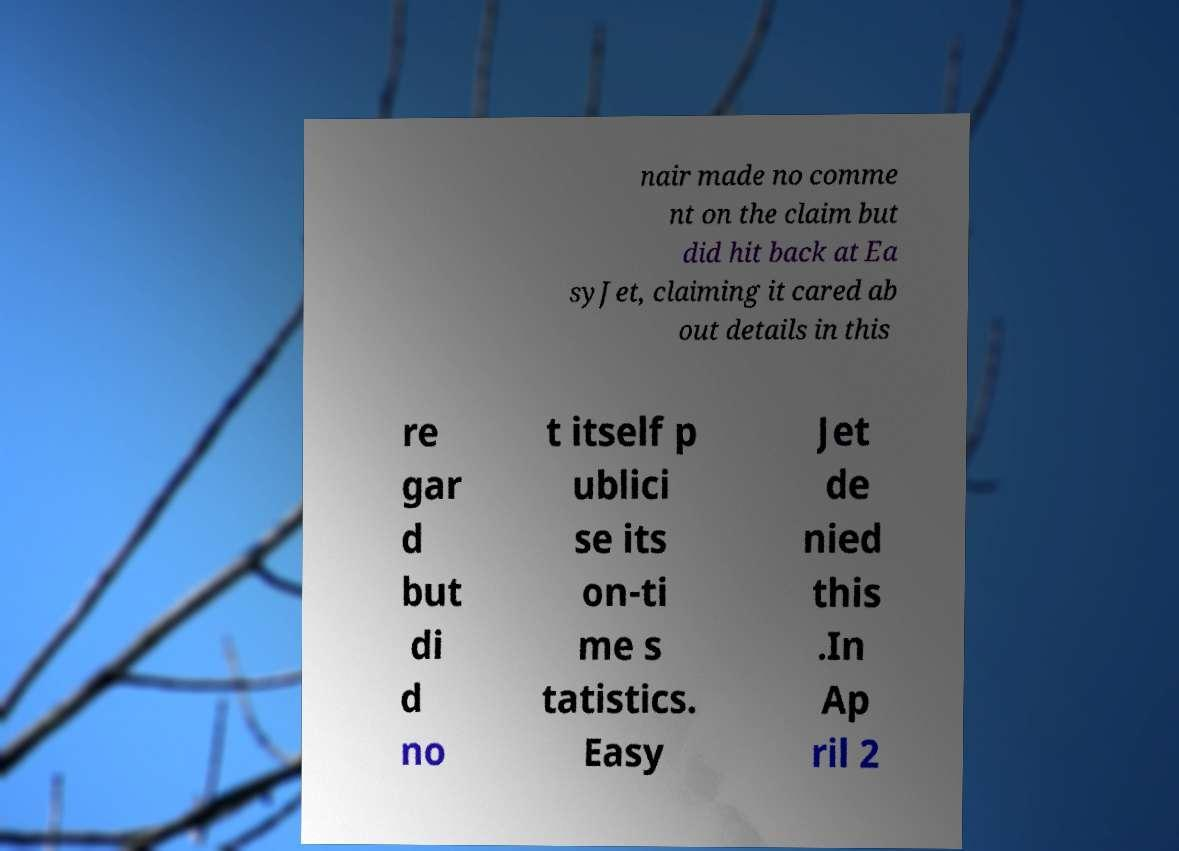Please identify and transcribe the text found in this image. nair made no comme nt on the claim but did hit back at Ea syJet, claiming it cared ab out details in this re gar d but di d no t itself p ublici se its on-ti me s tatistics. Easy Jet de nied this .In Ap ril 2 